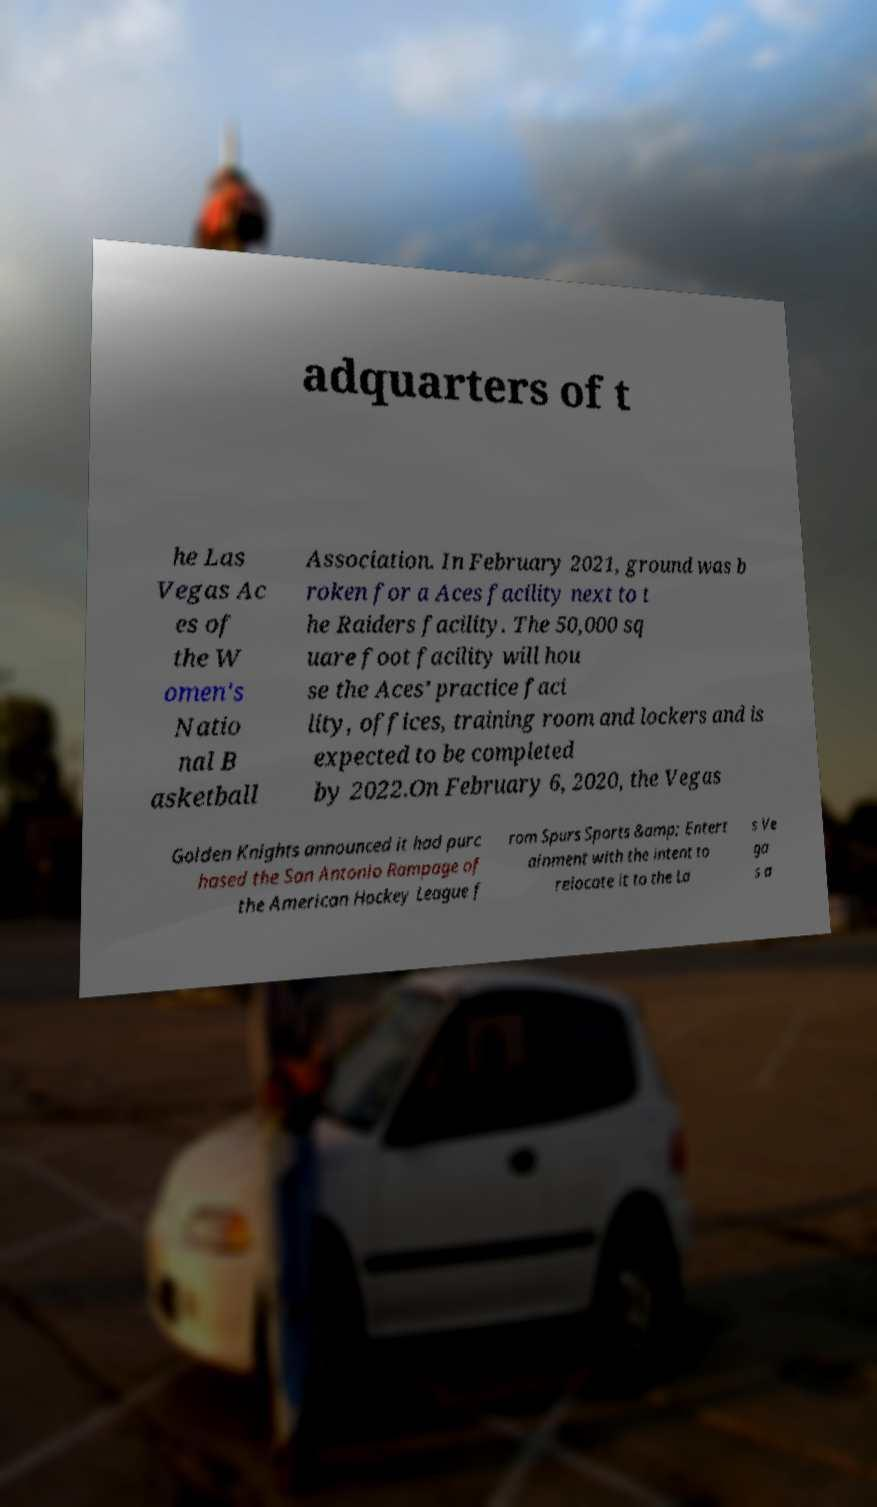What messages or text are displayed in this image? I need them in a readable, typed format. adquarters of t he Las Vegas Ac es of the W omen's Natio nal B asketball Association. In February 2021, ground was b roken for a Aces facility next to t he Raiders facility. The 50,000 sq uare foot facility will hou se the Aces’ practice faci lity, offices, training room and lockers and is expected to be completed by 2022.On February 6, 2020, the Vegas Golden Knights announced it had purc hased the San Antonio Rampage of the American Hockey League f rom Spurs Sports &amp; Entert ainment with the intent to relocate it to the La s Ve ga s a 